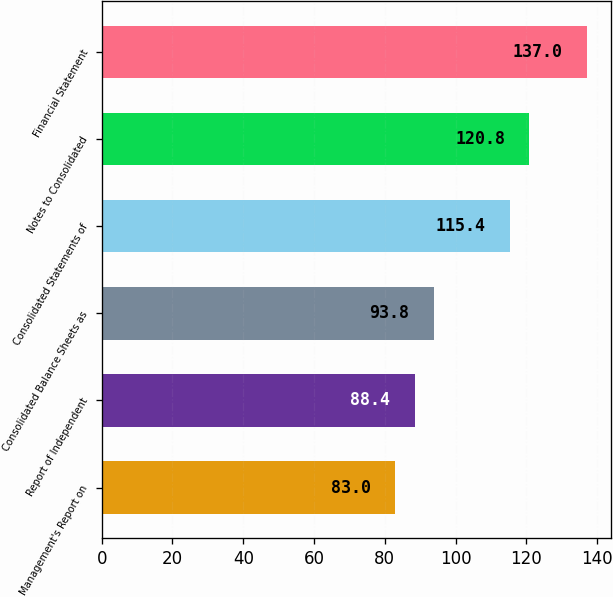Convert chart. <chart><loc_0><loc_0><loc_500><loc_500><bar_chart><fcel>Management's Report on<fcel>Report of Independent<fcel>Consolidated Balance Sheets as<fcel>Consolidated Statements of<fcel>Notes to Consolidated<fcel>Financial Statement<nl><fcel>83<fcel>88.4<fcel>93.8<fcel>115.4<fcel>120.8<fcel>137<nl></chart> 